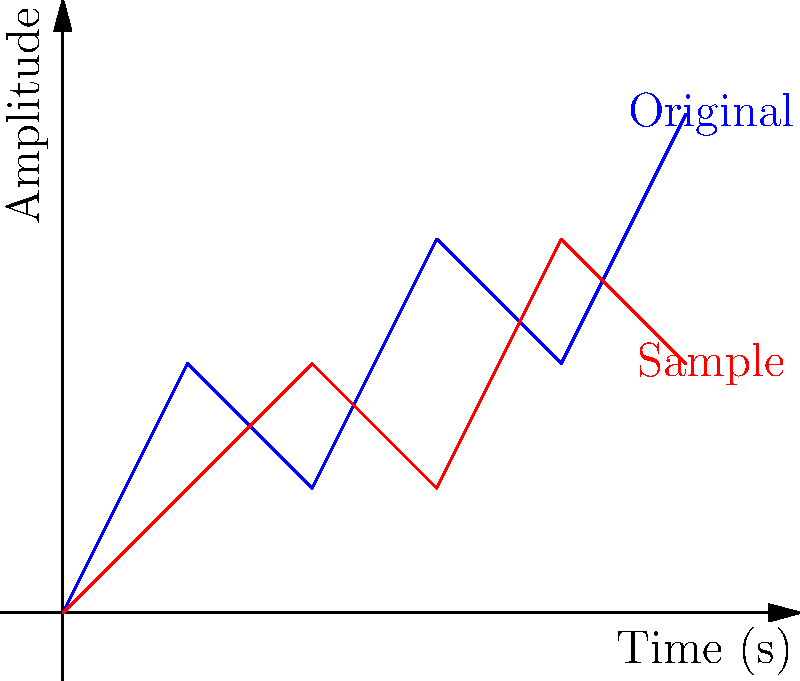In the graph above, the blue line represents an original audio track, and the red line represents a potentially sampled portion. As a music supervisor, you need to determine if the red sample is a copyright infringement. What key feature would you look for in the audio fingerprints to identify this as a potential match? To identify a potential copyright infringement using audio fingerprints, we need to look for similarities in the waveform patterns between the original track and the suspected sample. The process involves:

1. Analyzing the shape of the waveforms: Both the blue (original) and red (sample) lines show similar patterns of peaks and troughs.

2. Comparing the relative amplitudes: The red line appears to be a scaled-down version of the blue line, maintaining similar relative heights between peaks.

3. Examining the time alignment: The patterns in the red line closely follow those in the blue line, suggesting a temporal match.

4. Identifying unique features: Both waveforms share distinctive patterns, such as the dip at x=2 followed by a peak at x=3.

5. Considering the duration: The sample spans the entire time range of the original, indicating a substantial portion has been used.

The key feature to look for in audio fingerprints would be the pattern of relative peak positions and amplitudes over time. This pattern serves as a unique identifier for the audio, much like a fingerprint does for a person.

In this case, the similar shape, scaled amplitude, and temporal alignment of the red line to the blue line strongly suggest that the red sample is derived from the blue original, potentially indicating copyright infringement.
Answer: Pattern of relative peak positions and amplitudes over time 